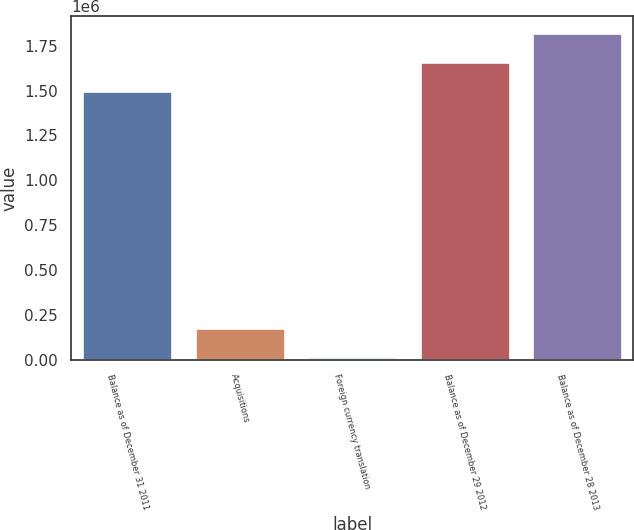Convert chart. <chart><loc_0><loc_0><loc_500><loc_500><bar_chart><fcel>Balance as of December 31 2011<fcel>Acquisitions<fcel>Foreign currency translation<fcel>Balance as of December 29 2012<fcel>Balance as of December 28 2013<nl><fcel>1.49711e+06<fcel>173747<fcel>11385<fcel>1.65947e+06<fcel>1.82183e+06<nl></chart> 